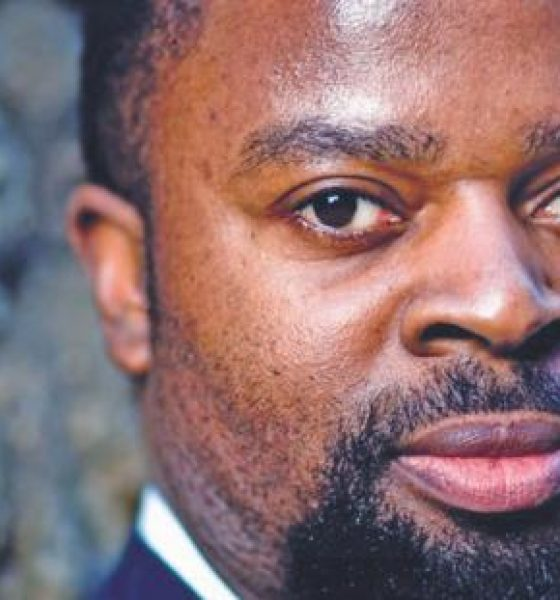If this person could travel anywhere in the world, where might they choose to go and why? If given the choice to travel anywhere in the world, this individual might choose to visit Kyoto, Japan. The city's blend of modernity and traditional culture, serene temples, and picturesque gardens provides the perfect escape. They could appreciate the tranquil environment, participate in a tea ceremony, and experience the deep history and art, offering a complete departure from their hectic professional life. 